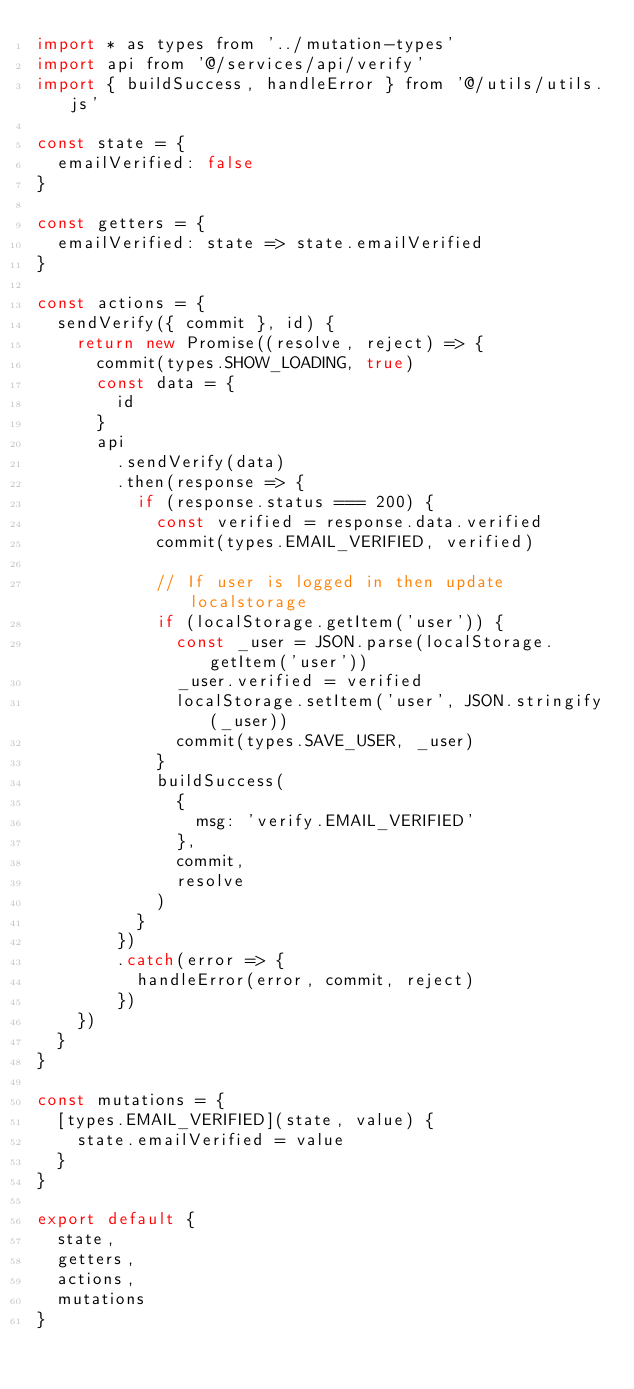Convert code to text. <code><loc_0><loc_0><loc_500><loc_500><_JavaScript_>import * as types from '../mutation-types'
import api from '@/services/api/verify'
import { buildSuccess, handleError } from '@/utils/utils.js'

const state = {
  emailVerified: false
}

const getters = {
  emailVerified: state => state.emailVerified
}

const actions = {
  sendVerify({ commit }, id) {
    return new Promise((resolve, reject) => {
      commit(types.SHOW_LOADING, true)
      const data = {
        id
      }
      api
        .sendVerify(data)
        .then(response => {
          if (response.status === 200) {
            const verified = response.data.verified
            commit(types.EMAIL_VERIFIED, verified)

            // If user is logged in then update localstorage
            if (localStorage.getItem('user')) {
              const _user = JSON.parse(localStorage.getItem('user'))
              _user.verified = verified
              localStorage.setItem('user', JSON.stringify(_user))
              commit(types.SAVE_USER, _user)
            }
            buildSuccess(
              {
                msg: 'verify.EMAIL_VERIFIED'
              },
              commit,
              resolve
            )
          }
        })
        .catch(error => {
          handleError(error, commit, reject)
        })
    })
  }
}

const mutations = {
  [types.EMAIL_VERIFIED](state, value) {
    state.emailVerified = value
  }
}

export default {
  state,
  getters,
  actions,
  mutations
}
</code> 